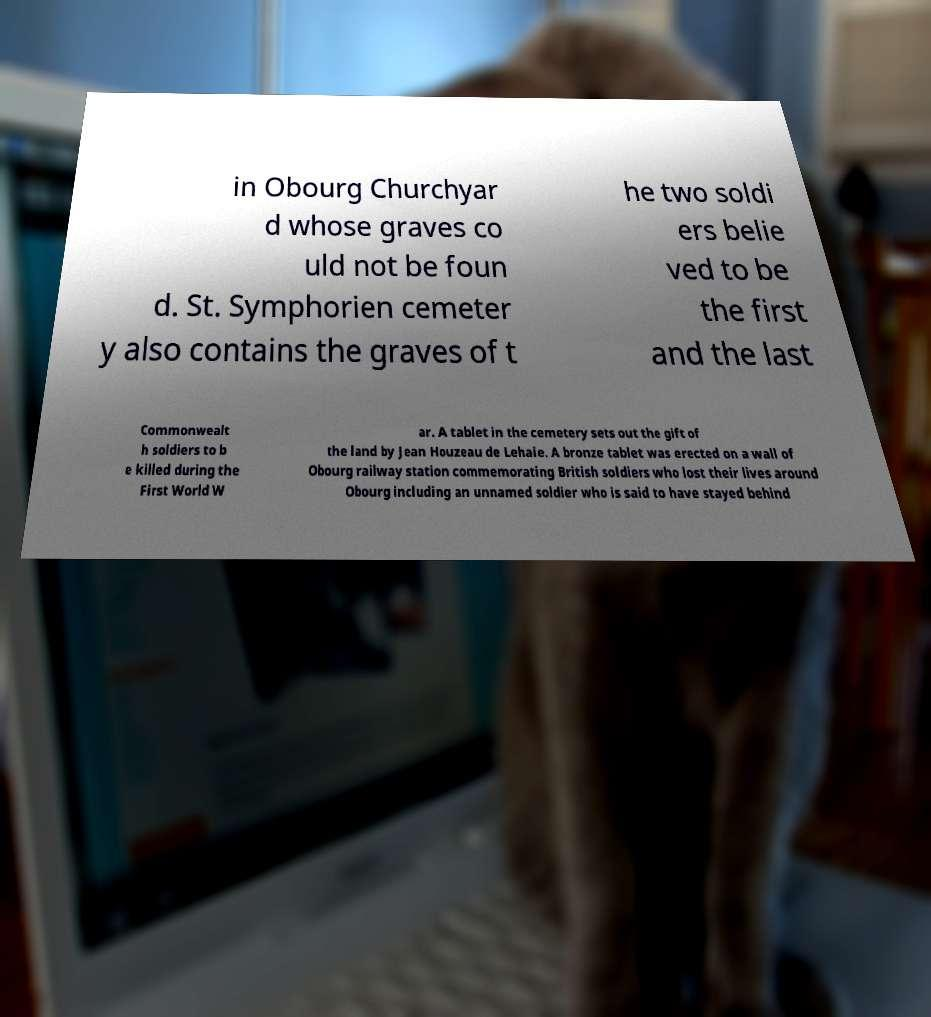Could you assist in decoding the text presented in this image and type it out clearly? in Obourg Churchyar d whose graves co uld not be foun d. St. Symphorien cemeter y also contains the graves of t he two soldi ers belie ved to be the first and the last Commonwealt h soldiers to b e killed during the First World W ar. A tablet in the cemetery sets out the gift of the land by Jean Houzeau de Lehaie. A bronze tablet was erected on a wall of Obourg railway station commemorating British soldiers who lost their lives around Obourg including an unnamed soldier who is said to have stayed behind 